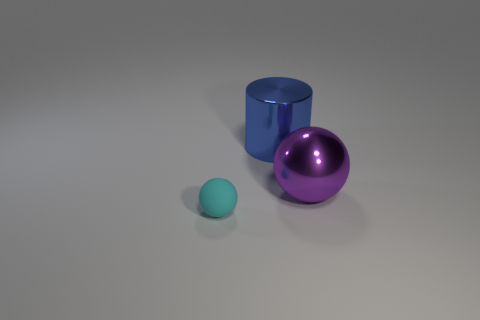There is a purple object that is the same size as the blue metallic object; what shape is it?
Provide a succinct answer. Sphere. The blue cylinder that is the same material as the purple ball is what size?
Your response must be concise. Large. Is the shape of the blue object the same as the big purple metal thing?
Your answer should be compact. No. There is a shiny ball that is the same size as the shiny cylinder; what color is it?
Ensure brevity in your answer.  Purple. There is another object that is the same shape as the cyan thing; what size is it?
Your response must be concise. Large. What shape is the large metal object in front of the big cylinder?
Keep it short and to the point. Sphere. Do the tiny rubber thing and the large metal object on the left side of the large sphere have the same shape?
Ensure brevity in your answer.  No. Are there the same number of big shiny cylinders behind the cylinder and big metal objects that are behind the large metallic ball?
Your answer should be compact. No. Are there more small cyan matte balls that are on the left side of the cyan thing than cyan rubber things?
Make the answer very short. No. What is the cylinder made of?
Give a very brief answer. Metal. 